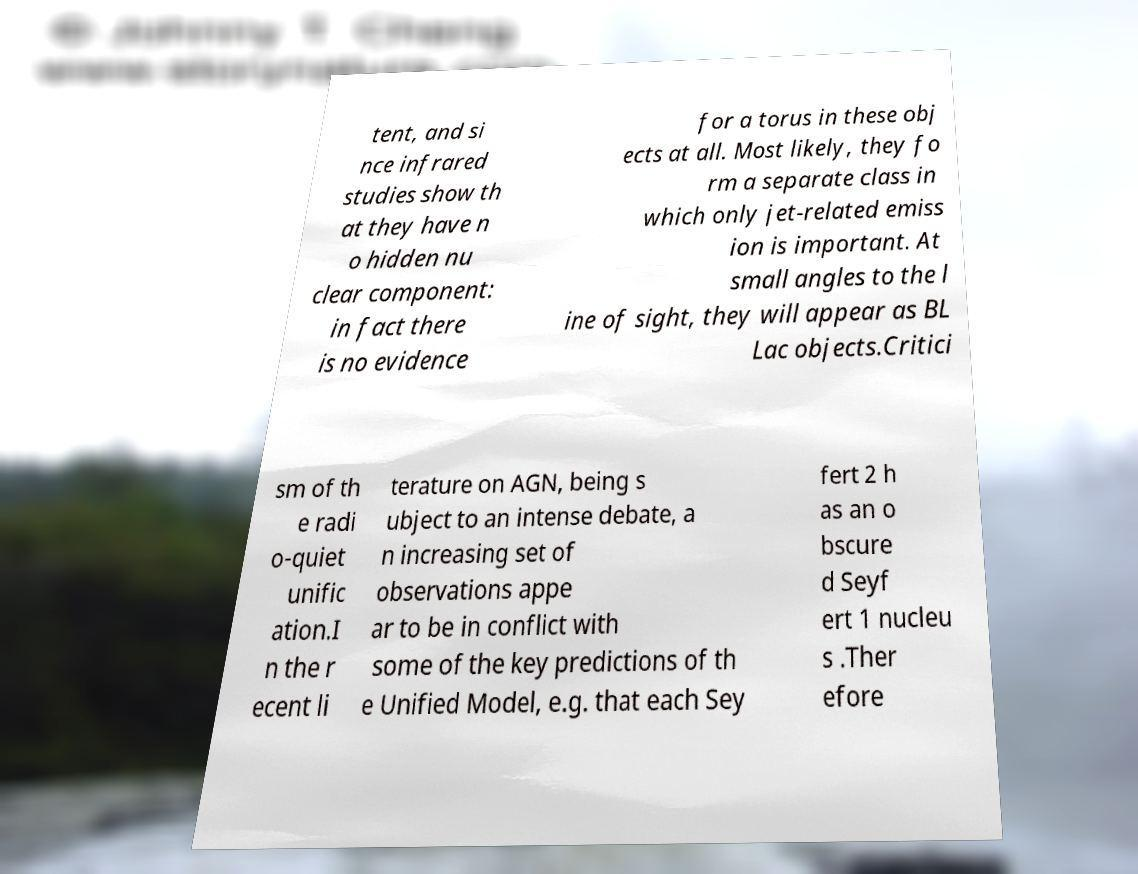Could you assist in decoding the text presented in this image and type it out clearly? tent, and si nce infrared studies show th at they have n o hidden nu clear component: in fact there is no evidence for a torus in these obj ects at all. Most likely, they fo rm a separate class in which only jet-related emiss ion is important. At small angles to the l ine of sight, they will appear as BL Lac objects.Critici sm of th e radi o-quiet unific ation.I n the r ecent li terature on AGN, being s ubject to an intense debate, a n increasing set of observations appe ar to be in conflict with some of the key predictions of th e Unified Model, e.g. that each Sey fert 2 h as an o bscure d Seyf ert 1 nucleu s .Ther efore 